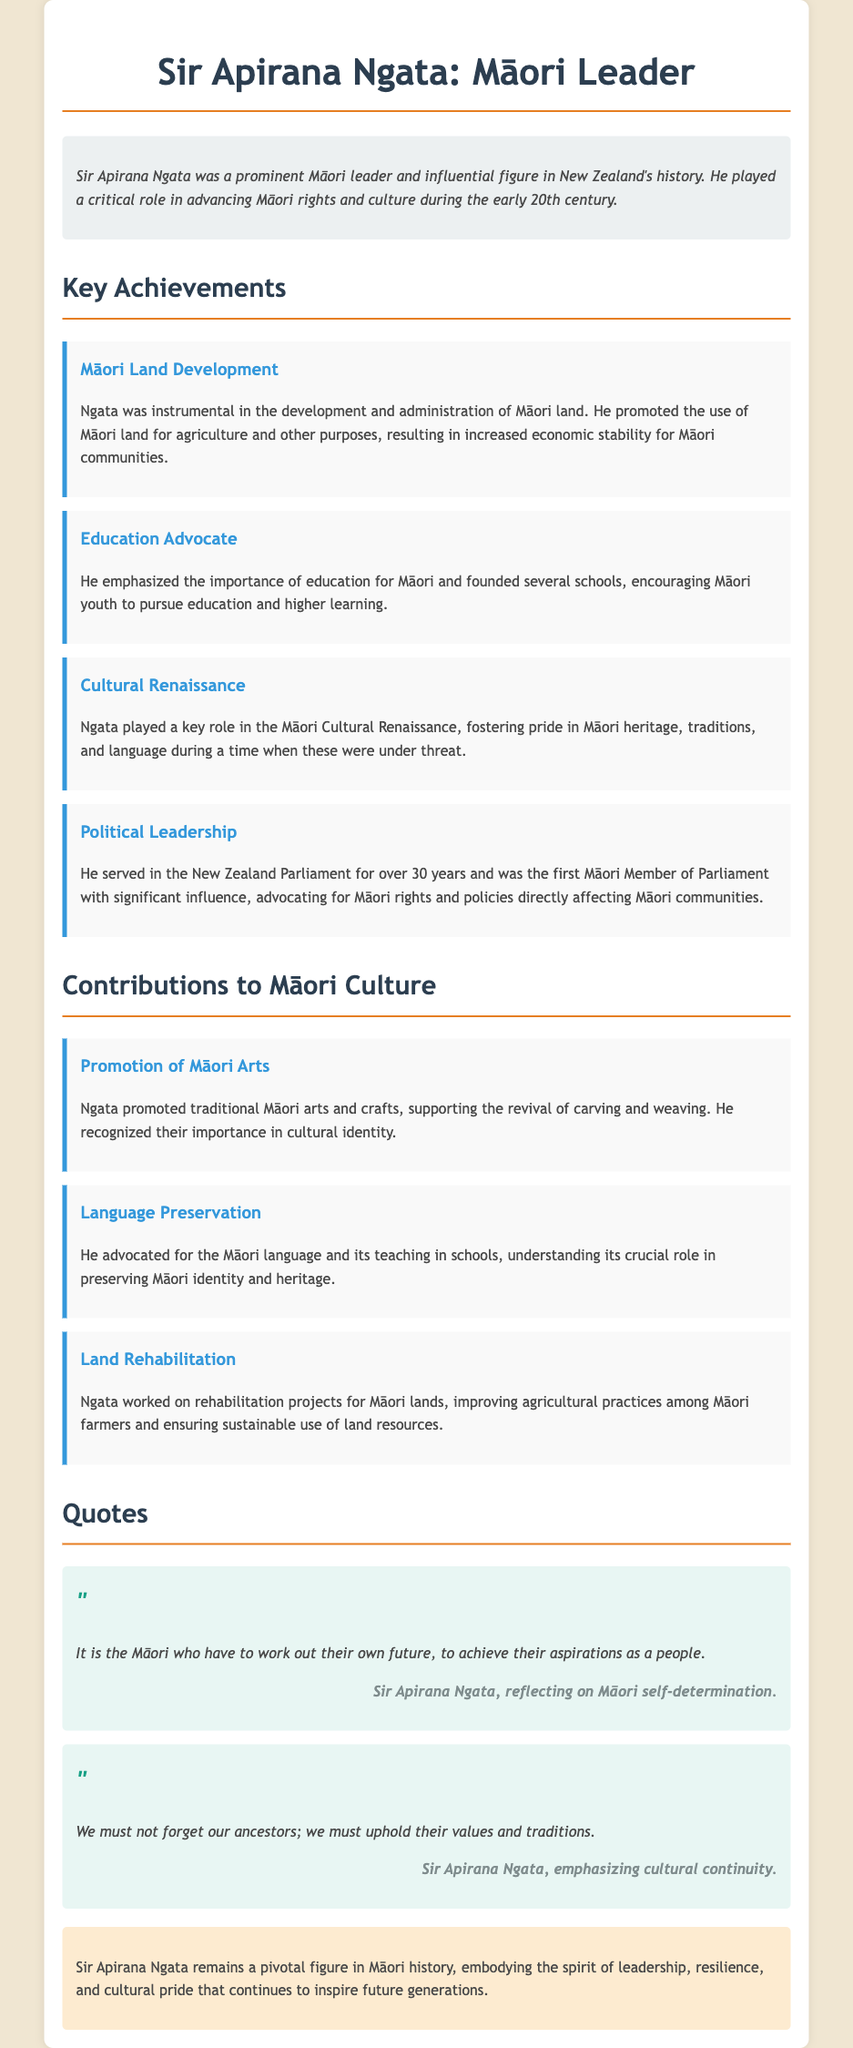what is Sir Apirana Ngata known for? Sir Apirana Ngata is known for being a prominent Māori leader and influential figure in New Zealand's history.
Answer: Māori leader how many years did Ngata serve in the New Zealand Parliament? Ngata served in the New Zealand Parliament for over 30 years.
Answer: over 30 years what cultural movement did Ngata contribute to? He played a key role in the Māori Cultural Renaissance.
Answer: Māori Cultural Renaissance which traditional arts did Ngata promote? Ngata promoted traditional Māori arts and crafts, including carving and weaving.
Answer: carving and weaving what did Ngata emphasize for Māori youth? He emphasized the importance of education for Māori youth.
Answer: education what are the first words of Ngata's quote about Māori self-determination? The first words of the quote are "It is the Māori".
Answer: It is the Māori what was one of Ngata's contributions to the Māori language? He advocated for the Māori language and its teaching in schools.
Answer: teaching in schools what type of projects did Ngata work on concerning Māori lands? He worked on rehabilitation projects for Māori lands.
Answer: rehabilitation projects what did Ngata say about ancestors and traditions? He stated, "We must not forget our ancestors; we must uphold their values and traditions."
Answer: uphold their values and traditions 